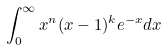<formula> <loc_0><loc_0><loc_500><loc_500>\int _ { 0 } ^ { \infty } x ^ { n } ( x - 1 ) ^ { k } e ^ { - x } d x</formula> 